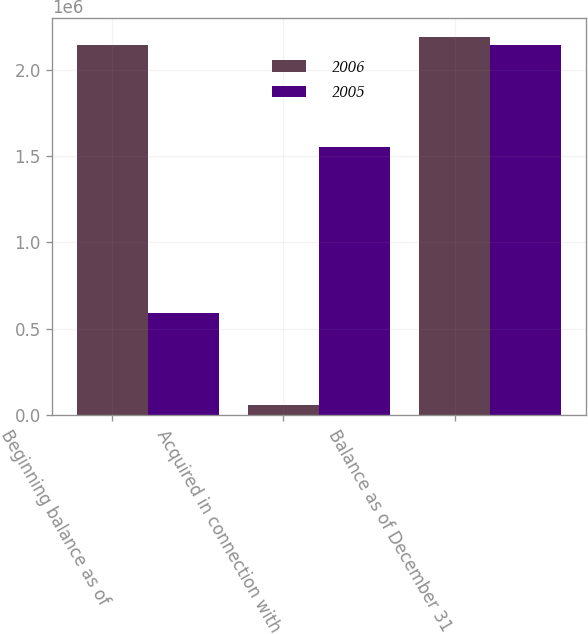Convert chart. <chart><loc_0><loc_0><loc_500><loc_500><stacked_bar_chart><ecel><fcel>Beginning balance as of<fcel>Acquired in connection with<fcel>Balance as of December 31<nl><fcel>2006<fcel>2.14255e+06<fcel>54463<fcel>2.18977e+06<nl><fcel>2005<fcel>592683<fcel>1.54987e+06<fcel>2.14255e+06<nl></chart> 